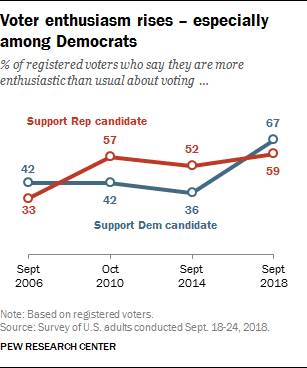Identify some key points in this picture. The value of a Support Rep candidate in the year September 2014 was 0.52. The value of voters who claim to be more enthusiastic than usual about voting in support of a Republican candidate is greater than the value of voters who support Democratic candidates. 